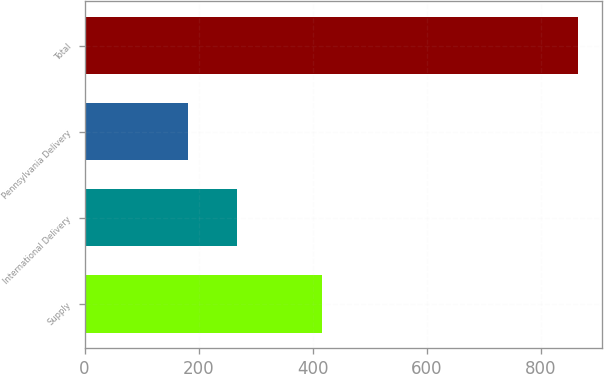Convert chart. <chart><loc_0><loc_0><loc_500><loc_500><bar_chart><fcel>Supply<fcel>International Delivery<fcel>Pennsylvania Delivery<fcel>Total<nl><fcel>416<fcel>268<fcel>181<fcel>865<nl></chart> 